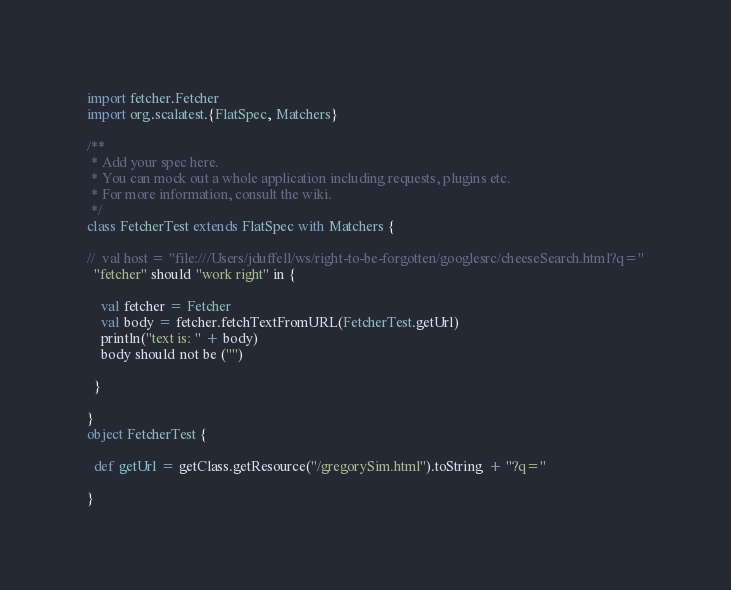Convert code to text. <code><loc_0><loc_0><loc_500><loc_500><_Scala_>import fetcher.Fetcher
import org.scalatest.{FlatSpec, Matchers}

/**
 * Add your spec here.
 * You can mock out a whole application including requests, plugins etc.
 * For more information, consult the wiki.
 */
class FetcherTest extends FlatSpec with Matchers {

//  val host = "file:///Users/jduffell/ws/right-to-be-forgotten/googlesrc/cheeseSearch.html?q="
  "fetcher" should "work right" in {

    val fetcher = Fetcher
    val body = fetcher.fetchTextFromURL(FetcherTest.getUrl)
    println("text is: " + body)
    body should not be ("")

  }

}
object FetcherTest {

  def getUrl = getClass.getResource("/gregorySim.html").toString + "?q="

}</code> 